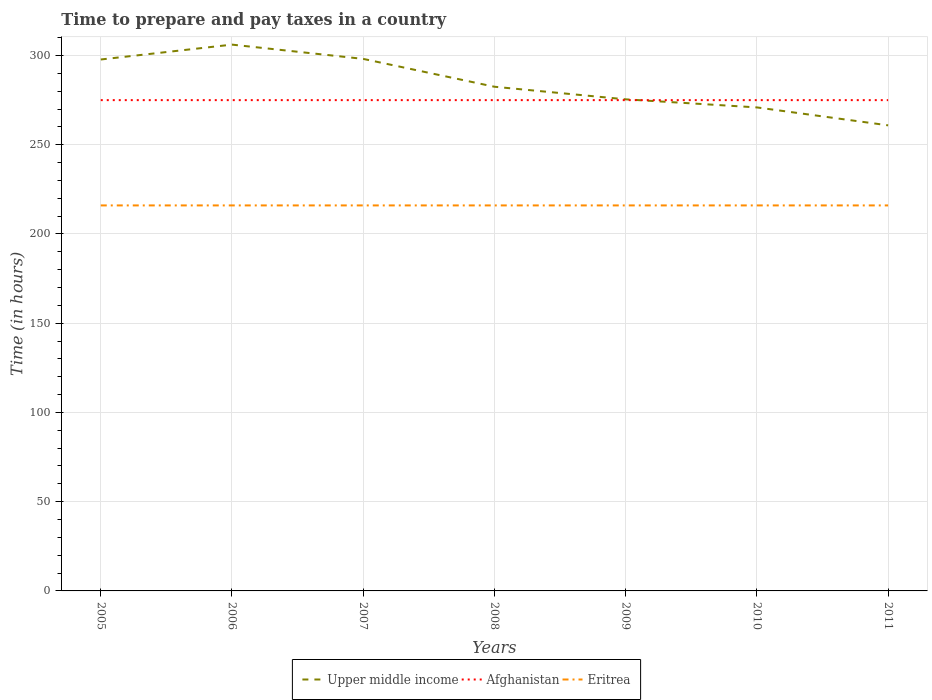How many different coloured lines are there?
Give a very brief answer. 3. Does the line corresponding to Afghanistan intersect with the line corresponding to Eritrea?
Keep it short and to the point. No. Is the number of lines equal to the number of legend labels?
Your response must be concise. Yes. Across all years, what is the maximum number of hours required to prepare and pay taxes in Eritrea?
Ensure brevity in your answer.  216. What is the total number of hours required to prepare and pay taxes in Afghanistan in the graph?
Give a very brief answer. 0. What is the difference between the highest and the second highest number of hours required to prepare and pay taxes in Upper middle income?
Your answer should be very brief. 45.23. Is the number of hours required to prepare and pay taxes in Eritrea strictly greater than the number of hours required to prepare and pay taxes in Afghanistan over the years?
Offer a very short reply. Yes. How many years are there in the graph?
Your answer should be compact. 7. Does the graph contain any zero values?
Provide a short and direct response. No. How many legend labels are there?
Your response must be concise. 3. How are the legend labels stacked?
Your answer should be compact. Horizontal. What is the title of the graph?
Offer a terse response. Time to prepare and pay taxes in a country. Does "Iraq" appear as one of the legend labels in the graph?
Give a very brief answer. No. What is the label or title of the Y-axis?
Your answer should be very brief. Time (in hours). What is the Time (in hours) in Upper middle income in 2005?
Provide a short and direct response. 297.76. What is the Time (in hours) of Afghanistan in 2005?
Your answer should be compact. 275. What is the Time (in hours) in Eritrea in 2005?
Your answer should be compact. 216. What is the Time (in hours) of Upper middle income in 2006?
Your answer should be very brief. 306.1. What is the Time (in hours) in Afghanistan in 2006?
Provide a short and direct response. 275. What is the Time (in hours) of Eritrea in 2006?
Give a very brief answer. 216. What is the Time (in hours) of Upper middle income in 2007?
Offer a very short reply. 298.1. What is the Time (in hours) in Afghanistan in 2007?
Your response must be concise. 275. What is the Time (in hours) of Eritrea in 2007?
Your response must be concise. 216. What is the Time (in hours) in Upper middle income in 2008?
Give a very brief answer. 282.5. What is the Time (in hours) in Afghanistan in 2008?
Ensure brevity in your answer.  275. What is the Time (in hours) in Eritrea in 2008?
Your answer should be compact. 216. What is the Time (in hours) in Upper middle income in 2009?
Offer a very short reply. 275.44. What is the Time (in hours) in Afghanistan in 2009?
Offer a very short reply. 275. What is the Time (in hours) in Eritrea in 2009?
Provide a short and direct response. 216. What is the Time (in hours) of Upper middle income in 2010?
Offer a very short reply. 270.91. What is the Time (in hours) in Afghanistan in 2010?
Ensure brevity in your answer.  275. What is the Time (in hours) in Eritrea in 2010?
Ensure brevity in your answer.  216. What is the Time (in hours) in Upper middle income in 2011?
Offer a very short reply. 260.87. What is the Time (in hours) of Afghanistan in 2011?
Give a very brief answer. 275. What is the Time (in hours) in Eritrea in 2011?
Provide a short and direct response. 216. Across all years, what is the maximum Time (in hours) of Upper middle income?
Your response must be concise. 306.1. Across all years, what is the maximum Time (in hours) of Afghanistan?
Give a very brief answer. 275. Across all years, what is the maximum Time (in hours) of Eritrea?
Give a very brief answer. 216. Across all years, what is the minimum Time (in hours) in Upper middle income?
Make the answer very short. 260.87. Across all years, what is the minimum Time (in hours) in Afghanistan?
Offer a very short reply. 275. Across all years, what is the minimum Time (in hours) in Eritrea?
Provide a succinct answer. 216. What is the total Time (in hours) of Upper middle income in the graph?
Offer a terse response. 1991.67. What is the total Time (in hours) of Afghanistan in the graph?
Keep it short and to the point. 1925. What is the total Time (in hours) in Eritrea in the graph?
Make the answer very short. 1512. What is the difference between the Time (in hours) of Upper middle income in 2005 and that in 2006?
Make the answer very short. -8.34. What is the difference between the Time (in hours) in Afghanistan in 2005 and that in 2006?
Make the answer very short. 0. What is the difference between the Time (in hours) in Eritrea in 2005 and that in 2006?
Your answer should be very brief. 0. What is the difference between the Time (in hours) in Upper middle income in 2005 and that in 2007?
Give a very brief answer. -0.34. What is the difference between the Time (in hours) of Afghanistan in 2005 and that in 2007?
Provide a short and direct response. 0. What is the difference between the Time (in hours) in Eritrea in 2005 and that in 2007?
Make the answer very short. 0. What is the difference between the Time (in hours) of Upper middle income in 2005 and that in 2008?
Your answer should be very brief. 15.27. What is the difference between the Time (in hours) of Eritrea in 2005 and that in 2008?
Offer a terse response. 0. What is the difference between the Time (in hours) of Upper middle income in 2005 and that in 2009?
Your answer should be very brief. 22.32. What is the difference between the Time (in hours) of Upper middle income in 2005 and that in 2010?
Your response must be concise. 26.85. What is the difference between the Time (in hours) of Afghanistan in 2005 and that in 2010?
Your response must be concise. 0. What is the difference between the Time (in hours) in Eritrea in 2005 and that in 2010?
Keep it short and to the point. 0. What is the difference between the Time (in hours) in Upper middle income in 2005 and that in 2011?
Provide a short and direct response. 36.89. What is the difference between the Time (in hours) of Afghanistan in 2005 and that in 2011?
Your answer should be very brief. 0. What is the difference between the Time (in hours) of Eritrea in 2005 and that in 2011?
Offer a very short reply. 0. What is the difference between the Time (in hours) in Upper middle income in 2006 and that in 2007?
Make the answer very short. 8. What is the difference between the Time (in hours) in Upper middle income in 2006 and that in 2008?
Offer a terse response. 23.6. What is the difference between the Time (in hours) in Upper middle income in 2006 and that in 2009?
Your answer should be compact. 30.66. What is the difference between the Time (in hours) of Eritrea in 2006 and that in 2009?
Give a very brief answer. 0. What is the difference between the Time (in hours) of Upper middle income in 2006 and that in 2010?
Give a very brief answer. 35.19. What is the difference between the Time (in hours) in Upper middle income in 2006 and that in 2011?
Your answer should be compact. 45.23. What is the difference between the Time (in hours) in Afghanistan in 2006 and that in 2011?
Your answer should be compact. 0. What is the difference between the Time (in hours) of Eritrea in 2006 and that in 2011?
Ensure brevity in your answer.  0. What is the difference between the Time (in hours) of Upper middle income in 2007 and that in 2008?
Provide a short and direct response. 15.6. What is the difference between the Time (in hours) in Upper middle income in 2007 and that in 2009?
Your answer should be very brief. 22.66. What is the difference between the Time (in hours) of Afghanistan in 2007 and that in 2009?
Your response must be concise. 0. What is the difference between the Time (in hours) in Eritrea in 2007 and that in 2009?
Provide a succinct answer. 0. What is the difference between the Time (in hours) of Upper middle income in 2007 and that in 2010?
Your answer should be very brief. 27.19. What is the difference between the Time (in hours) in Eritrea in 2007 and that in 2010?
Your answer should be compact. 0. What is the difference between the Time (in hours) in Upper middle income in 2007 and that in 2011?
Make the answer very short. 37.23. What is the difference between the Time (in hours) in Afghanistan in 2007 and that in 2011?
Give a very brief answer. 0. What is the difference between the Time (in hours) of Eritrea in 2007 and that in 2011?
Your answer should be compact. 0. What is the difference between the Time (in hours) of Upper middle income in 2008 and that in 2009?
Offer a terse response. 7.06. What is the difference between the Time (in hours) in Eritrea in 2008 and that in 2009?
Your response must be concise. 0. What is the difference between the Time (in hours) of Upper middle income in 2008 and that in 2010?
Offer a very short reply. 11.58. What is the difference between the Time (in hours) of Afghanistan in 2008 and that in 2010?
Provide a short and direct response. 0. What is the difference between the Time (in hours) in Eritrea in 2008 and that in 2010?
Offer a very short reply. 0. What is the difference between the Time (in hours) in Upper middle income in 2008 and that in 2011?
Your answer should be very brief. 21.63. What is the difference between the Time (in hours) of Afghanistan in 2008 and that in 2011?
Give a very brief answer. 0. What is the difference between the Time (in hours) of Eritrea in 2008 and that in 2011?
Provide a short and direct response. 0. What is the difference between the Time (in hours) in Upper middle income in 2009 and that in 2010?
Your answer should be very brief. 4.53. What is the difference between the Time (in hours) of Eritrea in 2009 and that in 2010?
Provide a succinct answer. 0. What is the difference between the Time (in hours) in Upper middle income in 2009 and that in 2011?
Offer a terse response. 14.57. What is the difference between the Time (in hours) of Afghanistan in 2009 and that in 2011?
Provide a short and direct response. 0. What is the difference between the Time (in hours) in Eritrea in 2009 and that in 2011?
Provide a succinct answer. 0. What is the difference between the Time (in hours) in Upper middle income in 2010 and that in 2011?
Provide a succinct answer. 10.04. What is the difference between the Time (in hours) in Upper middle income in 2005 and the Time (in hours) in Afghanistan in 2006?
Your answer should be very brief. 22.76. What is the difference between the Time (in hours) in Upper middle income in 2005 and the Time (in hours) in Eritrea in 2006?
Your response must be concise. 81.76. What is the difference between the Time (in hours) of Afghanistan in 2005 and the Time (in hours) of Eritrea in 2006?
Make the answer very short. 59. What is the difference between the Time (in hours) in Upper middle income in 2005 and the Time (in hours) in Afghanistan in 2007?
Provide a short and direct response. 22.76. What is the difference between the Time (in hours) in Upper middle income in 2005 and the Time (in hours) in Eritrea in 2007?
Provide a succinct answer. 81.76. What is the difference between the Time (in hours) of Afghanistan in 2005 and the Time (in hours) of Eritrea in 2007?
Provide a short and direct response. 59. What is the difference between the Time (in hours) of Upper middle income in 2005 and the Time (in hours) of Afghanistan in 2008?
Keep it short and to the point. 22.76. What is the difference between the Time (in hours) in Upper middle income in 2005 and the Time (in hours) in Eritrea in 2008?
Keep it short and to the point. 81.76. What is the difference between the Time (in hours) in Afghanistan in 2005 and the Time (in hours) in Eritrea in 2008?
Keep it short and to the point. 59. What is the difference between the Time (in hours) of Upper middle income in 2005 and the Time (in hours) of Afghanistan in 2009?
Your answer should be compact. 22.76. What is the difference between the Time (in hours) of Upper middle income in 2005 and the Time (in hours) of Eritrea in 2009?
Keep it short and to the point. 81.76. What is the difference between the Time (in hours) in Afghanistan in 2005 and the Time (in hours) in Eritrea in 2009?
Offer a very short reply. 59. What is the difference between the Time (in hours) of Upper middle income in 2005 and the Time (in hours) of Afghanistan in 2010?
Provide a short and direct response. 22.76. What is the difference between the Time (in hours) in Upper middle income in 2005 and the Time (in hours) in Eritrea in 2010?
Provide a short and direct response. 81.76. What is the difference between the Time (in hours) of Upper middle income in 2005 and the Time (in hours) of Afghanistan in 2011?
Offer a very short reply. 22.76. What is the difference between the Time (in hours) in Upper middle income in 2005 and the Time (in hours) in Eritrea in 2011?
Provide a succinct answer. 81.76. What is the difference between the Time (in hours) in Afghanistan in 2005 and the Time (in hours) in Eritrea in 2011?
Your answer should be very brief. 59. What is the difference between the Time (in hours) of Upper middle income in 2006 and the Time (in hours) of Afghanistan in 2007?
Provide a short and direct response. 31.1. What is the difference between the Time (in hours) of Upper middle income in 2006 and the Time (in hours) of Eritrea in 2007?
Provide a succinct answer. 90.1. What is the difference between the Time (in hours) of Afghanistan in 2006 and the Time (in hours) of Eritrea in 2007?
Offer a terse response. 59. What is the difference between the Time (in hours) in Upper middle income in 2006 and the Time (in hours) in Afghanistan in 2008?
Give a very brief answer. 31.1. What is the difference between the Time (in hours) of Upper middle income in 2006 and the Time (in hours) of Eritrea in 2008?
Offer a very short reply. 90.1. What is the difference between the Time (in hours) in Upper middle income in 2006 and the Time (in hours) in Afghanistan in 2009?
Offer a terse response. 31.1. What is the difference between the Time (in hours) in Upper middle income in 2006 and the Time (in hours) in Eritrea in 2009?
Your response must be concise. 90.1. What is the difference between the Time (in hours) in Upper middle income in 2006 and the Time (in hours) in Afghanistan in 2010?
Provide a succinct answer. 31.1. What is the difference between the Time (in hours) in Upper middle income in 2006 and the Time (in hours) in Eritrea in 2010?
Ensure brevity in your answer.  90.1. What is the difference between the Time (in hours) in Upper middle income in 2006 and the Time (in hours) in Afghanistan in 2011?
Ensure brevity in your answer.  31.1. What is the difference between the Time (in hours) of Upper middle income in 2006 and the Time (in hours) of Eritrea in 2011?
Provide a succinct answer. 90.1. What is the difference between the Time (in hours) in Upper middle income in 2007 and the Time (in hours) in Afghanistan in 2008?
Provide a succinct answer. 23.1. What is the difference between the Time (in hours) in Upper middle income in 2007 and the Time (in hours) in Eritrea in 2008?
Make the answer very short. 82.1. What is the difference between the Time (in hours) of Upper middle income in 2007 and the Time (in hours) of Afghanistan in 2009?
Provide a succinct answer. 23.1. What is the difference between the Time (in hours) in Upper middle income in 2007 and the Time (in hours) in Eritrea in 2009?
Make the answer very short. 82.1. What is the difference between the Time (in hours) of Afghanistan in 2007 and the Time (in hours) of Eritrea in 2009?
Give a very brief answer. 59. What is the difference between the Time (in hours) of Upper middle income in 2007 and the Time (in hours) of Afghanistan in 2010?
Your answer should be very brief. 23.1. What is the difference between the Time (in hours) of Upper middle income in 2007 and the Time (in hours) of Eritrea in 2010?
Provide a succinct answer. 82.1. What is the difference between the Time (in hours) in Afghanistan in 2007 and the Time (in hours) in Eritrea in 2010?
Make the answer very short. 59. What is the difference between the Time (in hours) in Upper middle income in 2007 and the Time (in hours) in Afghanistan in 2011?
Your answer should be very brief. 23.1. What is the difference between the Time (in hours) in Upper middle income in 2007 and the Time (in hours) in Eritrea in 2011?
Provide a short and direct response. 82.1. What is the difference between the Time (in hours) in Upper middle income in 2008 and the Time (in hours) in Afghanistan in 2009?
Your answer should be compact. 7.5. What is the difference between the Time (in hours) in Upper middle income in 2008 and the Time (in hours) in Eritrea in 2009?
Your answer should be very brief. 66.5. What is the difference between the Time (in hours) in Upper middle income in 2008 and the Time (in hours) in Afghanistan in 2010?
Your response must be concise. 7.5. What is the difference between the Time (in hours) in Upper middle income in 2008 and the Time (in hours) in Eritrea in 2010?
Offer a terse response. 66.5. What is the difference between the Time (in hours) of Afghanistan in 2008 and the Time (in hours) of Eritrea in 2010?
Provide a succinct answer. 59. What is the difference between the Time (in hours) of Upper middle income in 2008 and the Time (in hours) of Afghanistan in 2011?
Provide a succinct answer. 7.5. What is the difference between the Time (in hours) of Upper middle income in 2008 and the Time (in hours) of Eritrea in 2011?
Provide a succinct answer. 66.5. What is the difference between the Time (in hours) in Afghanistan in 2008 and the Time (in hours) in Eritrea in 2011?
Make the answer very short. 59. What is the difference between the Time (in hours) in Upper middle income in 2009 and the Time (in hours) in Afghanistan in 2010?
Provide a succinct answer. 0.44. What is the difference between the Time (in hours) of Upper middle income in 2009 and the Time (in hours) of Eritrea in 2010?
Provide a succinct answer. 59.44. What is the difference between the Time (in hours) in Afghanistan in 2009 and the Time (in hours) in Eritrea in 2010?
Your response must be concise. 59. What is the difference between the Time (in hours) in Upper middle income in 2009 and the Time (in hours) in Afghanistan in 2011?
Provide a succinct answer. 0.44. What is the difference between the Time (in hours) in Upper middle income in 2009 and the Time (in hours) in Eritrea in 2011?
Your answer should be compact. 59.44. What is the difference between the Time (in hours) of Upper middle income in 2010 and the Time (in hours) of Afghanistan in 2011?
Offer a very short reply. -4.09. What is the difference between the Time (in hours) of Upper middle income in 2010 and the Time (in hours) of Eritrea in 2011?
Provide a short and direct response. 54.91. What is the difference between the Time (in hours) in Afghanistan in 2010 and the Time (in hours) in Eritrea in 2011?
Offer a very short reply. 59. What is the average Time (in hours) of Upper middle income per year?
Offer a very short reply. 284.52. What is the average Time (in hours) of Afghanistan per year?
Give a very brief answer. 275. What is the average Time (in hours) of Eritrea per year?
Provide a succinct answer. 216. In the year 2005, what is the difference between the Time (in hours) of Upper middle income and Time (in hours) of Afghanistan?
Make the answer very short. 22.76. In the year 2005, what is the difference between the Time (in hours) of Upper middle income and Time (in hours) of Eritrea?
Your answer should be very brief. 81.76. In the year 2006, what is the difference between the Time (in hours) of Upper middle income and Time (in hours) of Afghanistan?
Your answer should be very brief. 31.1. In the year 2006, what is the difference between the Time (in hours) of Upper middle income and Time (in hours) of Eritrea?
Offer a very short reply. 90.1. In the year 2006, what is the difference between the Time (in hours) of Afghanistan and Time (in hours) of Eritrea?
Your answer should be very brief. 59. In the year 2007, what is the difference between the Time (in hours) of Upper middle income and Time (in hours) of Afghanistan?
Keep it short and to the point. 23.1. In the year 2007, what is the difference between the Time (in hours) of Upper middle income and Time (in hours) of Eritrea?
Your response must be concise. 82.1. In the year 2008, what is the difference between the Time (in hours) of Upper middle income and Time (in hours) of Afghanistan?
Ensure brevity in your answer.  7.5. In the year 2008, what is the difference between the Time (in hours) of Upper middle income and Time (in hours) of Eritrea?
Offer a very short reply. 66.5. In the year 2009, what is the difference between the Time (in hours) in Upper middle income and Time (in hours) in Afghanistan?
Ensure brevity in your answer.  0.44. In the year 2009, what is the difference between the Time (in hours) in Upper middle income and Time (in hours) in Eritrea?
Ensure brevity in your answer.  59.44. In the year 2009, what is the difference between the Time (in hours) in Afghanistan and Time (in hours) in Eritrea?
Keep it short and to the point. 59. In the year 2010, what is the difference between the Time (in hours) of Upper middle income and Time (in hours) of Afghanistan?
Provide a short and direct response. -4.09. In the year 2010, what is the difference between the Time (in hours) of Upper middle income and Time (in hours) of Eritrea?
Provide a short and direct response. 54.91. In the year 2010, what is the difference between the Time (in hours) in Afghanistan and Time (in hours) in Eritrea?
Give a very brief answer. 59. In the year 2011, what is the difference between the Time (in hours) in Upper middle income and Time (in hours) in Afghanistan?
Offer a very short reply. -14.13. In the year 2011, what is the difference between the Time (in hours) of Upper middle income and Time (in hours) of Eritrea?
Give a very brief answer. 44.87. In the year 2011, what is the difference between the Time (in hours) in Afghanistan and Time (in hours) in Eritrea?
Keep it short and to the point. 59. What is the ratio of the Time (in hours) in Upper middle income in 2005 to that in 2006?
Give a very brief answer. 0.97. What is the ratio of the Time (in hours) of Afghanistan in 2005 to that in 2006?
Provide a short and direct response. 1. What is the ratio of the Time (in hours) of Eritrea in 2005 to that in 2007?
Give a very brief answer. 1. What is the ratio of the Time (in hours) in Upper middle income in 2005 to that in 2008?
Your response must be concise. 1.05. What is the ratio of the Time (in hours) in Afghanistan in 2005 to that in 2008?
Provide a short and direct response. 1. What is the ratio of the Time (in hours) in Eritrea in 2005 to that in 2008?
Your response must be concise. 1. What is the ratio of the Time (in hours) in Upper middle income in 2005 to that in 2009?
Offer a terse response. 1.08. What is the ratio of the Time (in hours) in Upper middle income in 2005 to that in 2010?
Give a very brief answer. 1.1. What is the ratio of the Time (in hours) in Afghanistan in 2005 to that in 2010?
Keep it short and to the point. 1. What is the ratio of the Time (in hours) in Upper middle income in 2005 to that in 2011?
Ensure brevity in your answer.  1.14. What is the ratio of the Time (in hours) in Upper middle income in 2006 to that in 2007?
Your answer should be compact. 1.03. What is the ratio of the Time (in hours) of Upper middle income in 2006 to that in 2008?
Your response must be concise. 1.08. What is the ratio of the Time (in hours) of Upper middle income in 2006 to that in 2009?
Offer a very short reply. 1.11. What is the ratio of the Time (in hours) in Eritrea in 2006 to that in 2009?
Your answer should be very brief. 1. What is the ratio of the Time (in hours) of Upper middle income in 2006 to that in 2010?
Give a very brief answer. 1.13. What is the ratio of the Time (in hours) of Upper middle income in 2006 to that in 2011?
Keep it short and to the point. 1.17. What is the ratio of the Time (in hours) in Afghanistan in 2006 to that in 2011?
Give a very brief answer. 1. What is the ratio of the Time (in hours) of Upper middle income in 2007 to that in 2008?
Give a very brief answer. 1.06. What is the ratio of the Time (in hours) in Upper middle income in 2007 to that in 2009?
Provide a short and direct response. 1.08. What is the ratio of the Time (in hours) in Eritrea in 2007 to that in 2009?
Your answer should be compact. 1. What is the ratio of the Time (in hours) of Upper middle income in 2007 to that in 2010?
Offer a very short reply. 1.1. What is the ratio of the Time (in hours) in Eritrea in 2007 to that in 2010?
Provide a short and direct response. 1. What is the ratio of the Time (in hours) of Upper middle income in 2007 to that in 2011?
Your answer should be very brief. 1.14. What is the ratio of the Time (in hours) of Upper middle income in 2008 to that in 2009?
Provide a succinct answer. 1.03. What is the ratio of the Time (in hours) of Upper middle income in 2008 to that in 2010?
Offer a terse response. 1.04. What is the ratio of the Time (in hours) in Eritrea in 2008 to that in 2010?
Your answer should be very brief. 1. What is the ratio of the Time (in hours) in Upper middle income in 2008 to that in 2011?
Ensure brevity in your answer.  1.08. What is the ratio of the Time (in hours) of Upper middle income in 2009 to that in 2010?
Your response must be concise. 1.02. What is the ratio of the Time (in hours) of Upper middle income in 2009 to that in 2011?
Offer a very short reply. 1.06. What is the ratio of the Time (in hours) in Eritrea in 2010 to that in 2011?
Provide a short and direct response. 1. What is the difference between the highest and the second highest Time (in hours) in Afghanistan?
Offer a very short reply. 0. What is the difference between the highest and the lowest Time (in hours) of Upper middle income?
Make the answer very short. 45.23. What is the difference between the highest and the lowest Time (in hours) in Afghanistan?
Ensure brevity in your answer.  0. What is the difference between the highest and the lowest Time (in hours) in Eritrea?
Offer a very short reply. 0. 